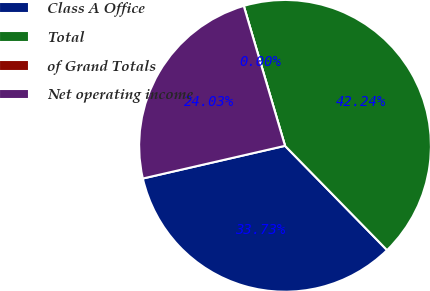Convert chart to OTSL. <chart><loc_0><loc_0><loc_500><loc_500><pie_chart><fcel>Class A Office<fcel>Total<fcel>of Grand Totals<fcel>Net operating income<nl><fcel>33.73%<fcel>42.24%<fcel>0.0%<fcel>24.03%<nl></chart> 